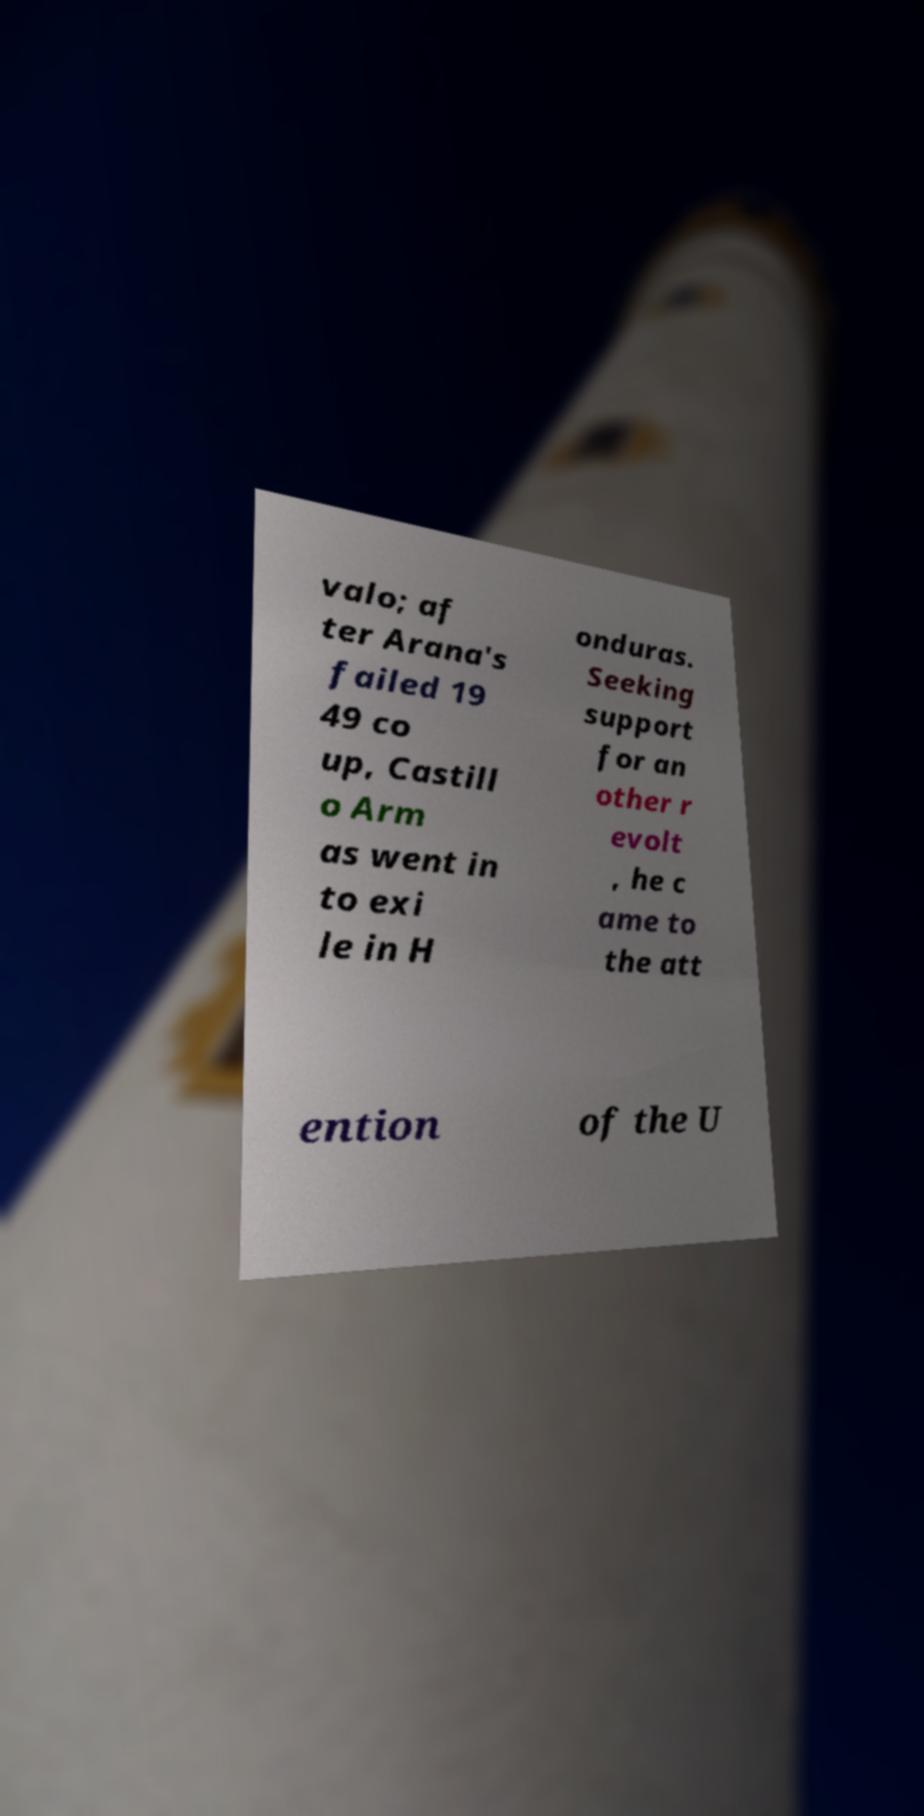Could you extract and type out the text from this image? valo; af ter Arana's failed 19 49 co up, Castill o Arm as went in to exi le in H onduras. Seeking support for an other r evolt , he c ame to the att ention of the U 